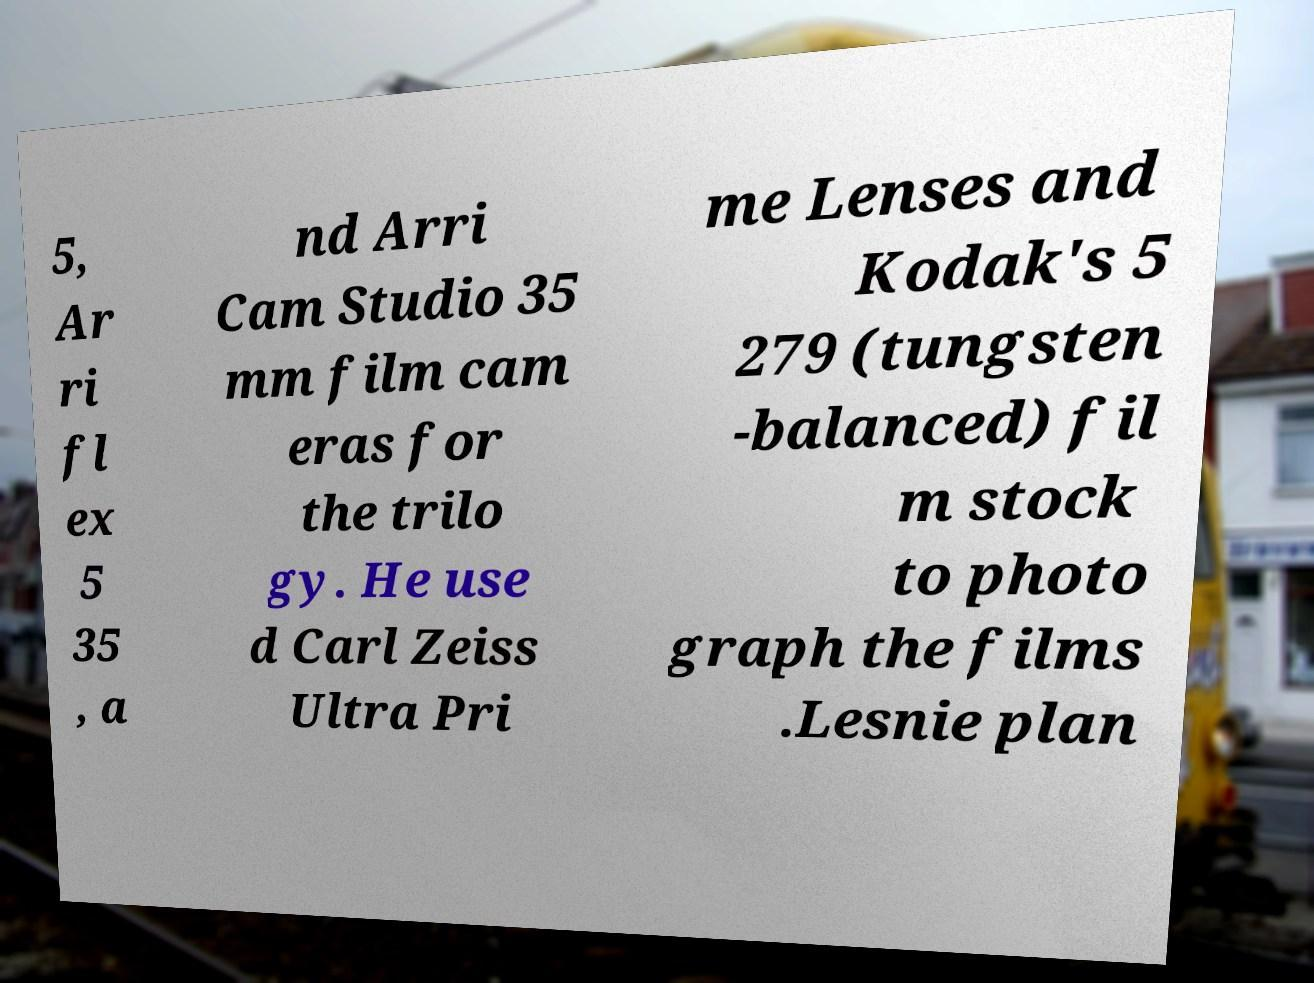Could you assist in decoding the text presented in this image and type it out clearly? 5, Ar ri fl ex 5 35 , a nd Arri Cam Studio 35 mm film cam eras for the trilo gy. He use d Carl Zeiss Ultra Pri me Lenses and Kodak's 5 279 (tungsten -balanced) fil m stock to photo graph the films .Lesnie plan 